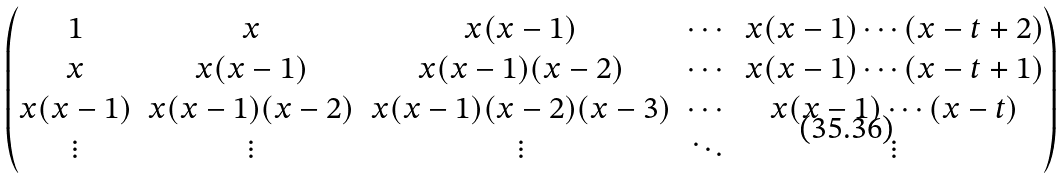<formula> <loc_0><loc_0><loc_500><loc_500>\begin{pmatrix} 1 & x & x ( x - 1 ) & \cdots & x ( x - 1 ) \cdots ( x - t + 2 ) \\ x & x ( x - 1 ) & x ( x - 1 ) ( x - 2 ) & \cdots & x ( x - 1 ) \cdots ( x - t + 1 ) \\ x ( x - 1 ) & x ( x - 1 ) ( x - 2 ) & x ( x - 1 ) ( x - 2 ) ( x - 3 ) & \cdots & x ( x - 1 ) \cdots ( x - t ) \\ \vdots & \vdots & \vdots & \ddots & \vdots \end{pmatrix}</formula> 